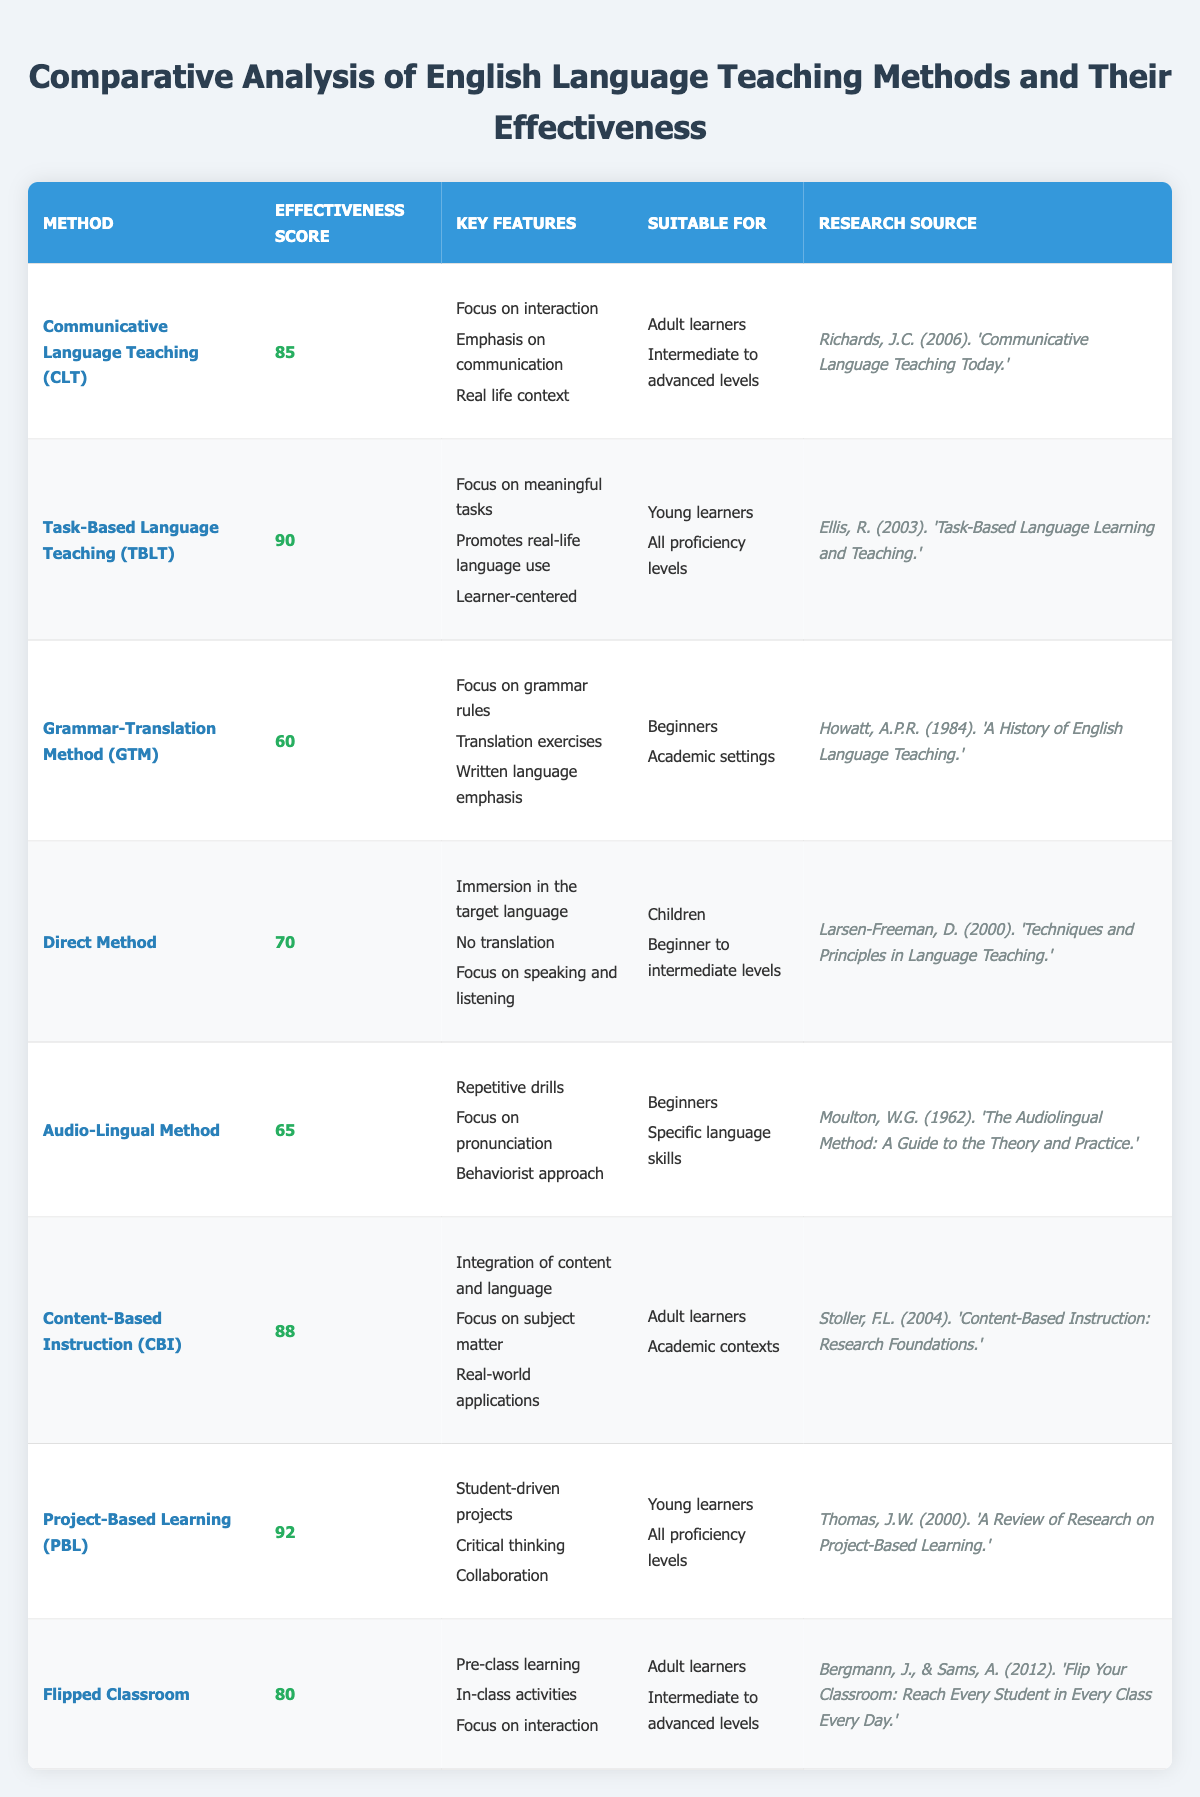What is the effectiveness score of Task-Based Language Teaching? The effectiveness score for Task-Based Language Teaching is explicitly listed in the table as 90.
Answer: 90 Which teaching method is suitable for beginners and academic settings? The Grammar-Translation Method is identified in the table as suitable for beginners and specifically mentions academic settings.
Answer: Grammar-Translation Method What are the key features of Content-Based Instruction? The key features listed for Content-Based Instruction in the table include integration of content and language, focus on subject matter, and real-world applications.
Answer: Integration of content and language, focus on subject matter, real-world applications Which method has the highest effectiveness score, and what is that score? By examining the effectiveness scores in the table, Project-Based Learning has the highest score of 92.
Answer: Project-Based Learning, 92 Is the Flipped Classroom suitable for young learners? The table indicates that the Flipped Classroom is suitable for adult learners and intermediate to advanced levels, not for young learners.
Answer: No What is the average effectiveness score of the methods suitable for adult learners? The effectiveness scores for methods suitable for adult learners (CLT, CBI, Flipped Classroom) are 85, 88, and 80. Summing them gives 253, and dividing by 3 gives an average of 84.33.
Answer: 84.33 How many methods have an effectiveness score above 80? Looking at the table, the methods with scores above 80 are Task-Based Language Teaching (90), Content-Based Instruction (88), Project-Based Learning (92), and Flipped Classroom (80). This totals to 4 methods.
Answer: 4 Which teaching method emphasizes speaking and listening without translation? The Direct Method is noted in the table for its emphasis on speaking and listening, and it specifically mentions no translation.
Answer: Direct Method What is the difference in effectiveness scores between the highest and lowest scoring methods? The highest score is 92 (Project-Based Learning) and the lowest is 60 (Grammar-Translation Method). The difference is 92 - 60, which equals 32.
Answer: 32 Are there any methods suitable for young learners that have effectiveness scores above 85? The Task-Based Language Teaching (TBLT, 90) and Project-Based Learning (PBL, 92) are both suitable for young learners and have effectiveness scores above 85.
Answer: Yes, TBLT and PBL 